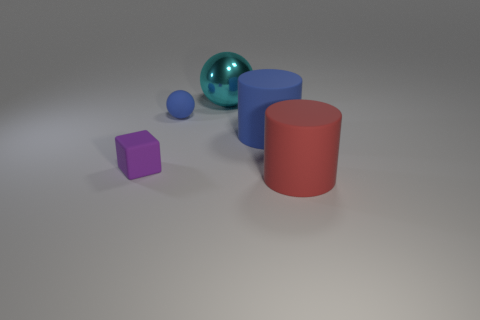What is the color of the large object that is in front of the small purple cube left of the red matte cylinder?
Provide a short and direct response. Red. How many other things are the same shape as the big blue thing?
Ensure brevity in your answer.  1. Is there a purple thing made of the same material as the small blue ball?
Your answer should be very brief. Yes. There is a sphere that is the same size as the blue cylinder; what material is it?
Your answer should be compact. Metal. The sphere in front of the thing that is behind the blue rubber thing that is on the left side of the large cyan thing is what color?
Make the answer very short. Blue. There is a blue object left of the large cyan thing; is its shape the same as the big thing left of the big blue rubber thing?
Provide a succinct answer. Yes. How many small purple matte cubes are there?
Your response must be concise. 1. What color is the other rubber cylinder that is the same size as the red matte cylinder?
Your response must be concise. Blue. Is the blue object right of the large cyan sphere made of the same material as the ball that is on the left side of the big ball?
Offer a terse response. Yes. There is a thing that is to the left of the tiny thing that is right of the purple thing; what size is it?
Offer a terse response. Small. 